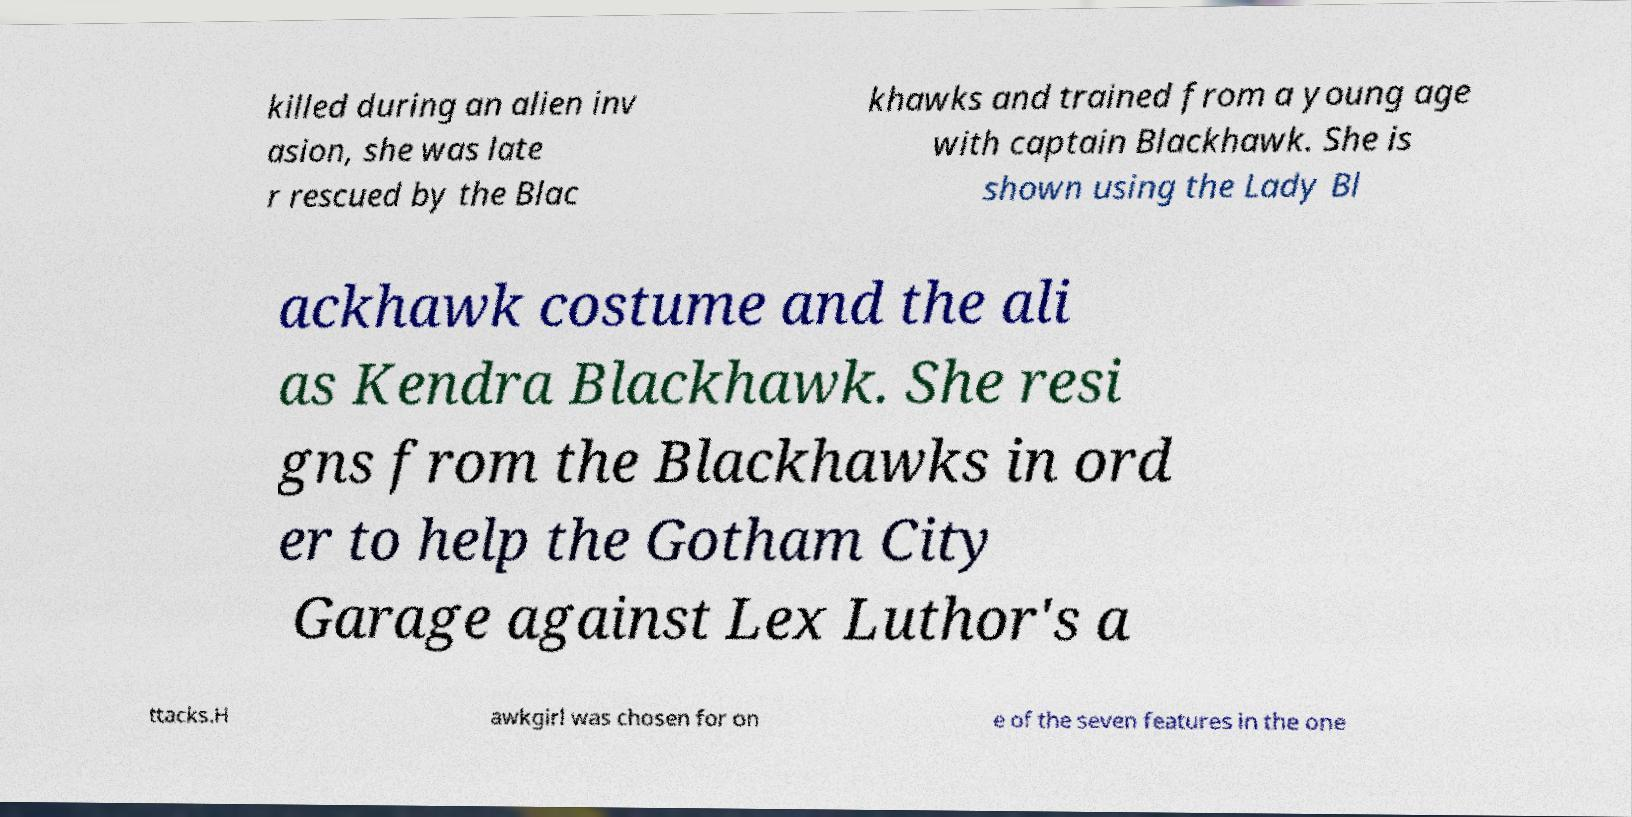Can you read and provide the text displayed in the image?This photo seems to have some interesting text. Can you extract and type it out for me? killed during an alien inv asion, she was late r rescued by the Blac khawks and trained from a young age with captain Blackhawk. She is shown using the Lady Bl ackhawk costume and the ali as Kendra Blackhawk. She resi gns from the Blackhawks in ord er to help the Gotham City Garage against Lex Luthor's a ttacks.H awkgirl was chosen for on e of the seven features in the one 